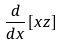<formula> <loc_0><loc_0><loc_500><loc_500>\frac { d } { d x } [ x z ]</formula> 